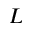<formula> <loc_0><loc_0><loc_500><loc_500>L</formula> 